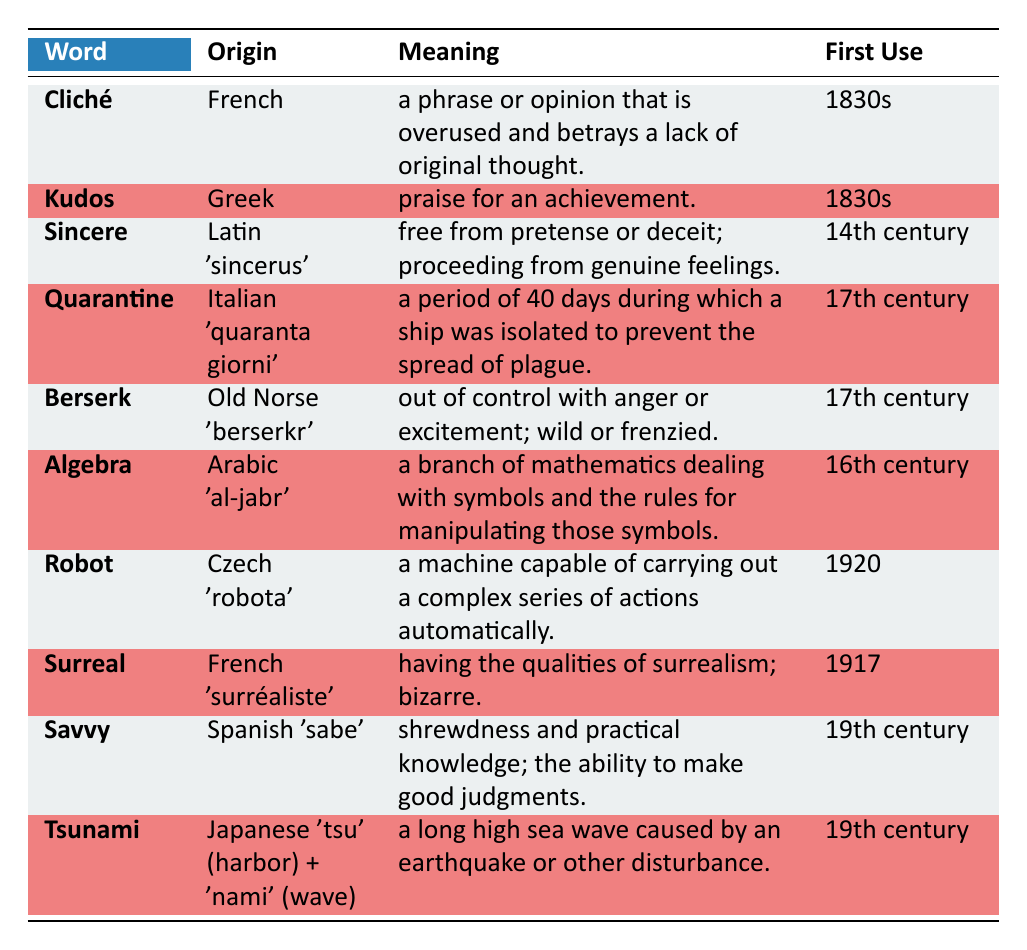What is the origin of the word "Cliché"? The table indicates that the word "Cliché" comes from French.
Answer: French In which century was the word "Algebra" first used? According to the table, "Algebra" was first used in the 16th century.
Answer: 16th century Is "Kudos" derived from Latin? The table shows that "Kudos" has its origin in Greek, not Latin, therefore the answer is no.
Answer: No What is the meaning of the word "Surreal"? From the table, "Surreal" is defined as having the qualities of surrealism; bizarre.
Answer: Having the qualities of surrealism; bizarre How many words listed in the table have origins from French? The words "Cliché" and "Surreal" both originate from French, totaling 2 words.
Answer: 2 What is the first use time of the word "Robot"? The data indicates that "Robot" was first used in the year 1920, according to the table.
Answer: 1920 Is the meaning of "Sincere" related to feelings? The table describes "Sincere" as free from pretense or deceit; proceeding from genuine feelings, confirming that the answer is yes.
Answer: Yes Which word has the earliest first use and in what century? The table shows that "Sincere" has the earliest first use in the 14th century.
Answer: 14th century What is the combined origin of the word "Tsunami"? The table indicates that "Tsunami" originates from Japanese, specifically from "tsu" meaning harbor and "nami" meaning wave, hence it's a combination of these two parts.
Answer: Japanese 'tsu' (harbor) + 'nami' (wave) What does "Berserk" mean? The table states that "Berserk" means out of control with anger or excitement; wild or frenzied.
Answer: Out of control with anger or excitement; wild or frenzied 